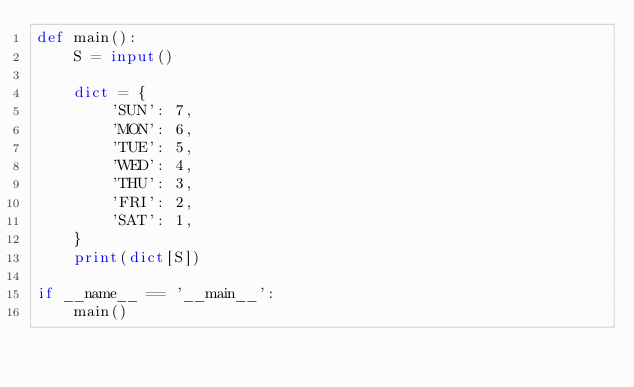<code> <loc_0><loc_0><loc_500><loc_500><_Python_>def main():
    S = input()

    dict = {
        'SUN': 7,
        'MON': 6,
        'TUE': 5,
        'WED': 4,
        'THU': 3,
        'FRI': 2,
        'SAT': 1,
    }
    print(dict[S])

if __name__ == '__main__':
    main()</code> 